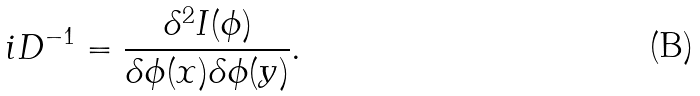Convert formula to latex. <formula><loc_0><loc_0><loc_500><loc_500>i D ^ { - 1 } = \frac { \delta ^ { 2 } I ( \phi ) } { \delta \phi ( x ) \delta \phi ( y ) } .</formula> 